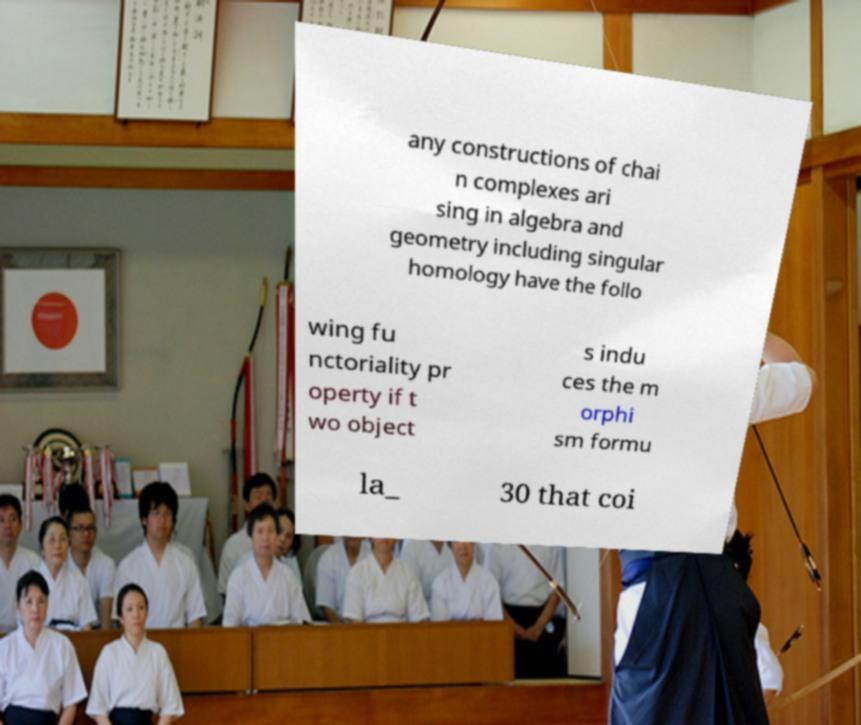I need the written content from this picture converted into text. Can you do that? any constructions of chai n complexes ari sing in algebra and geometry including singular homology have the follo wing fu nctoriality pr operty if t wo object s indu ces the m orphi sm formu la_ 30 that coi 